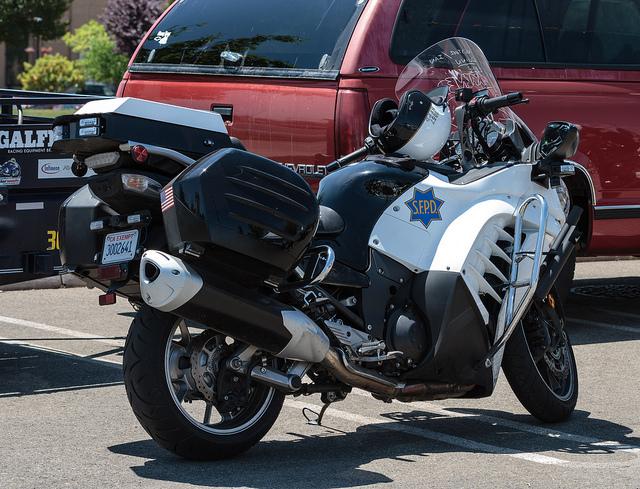Is the motorcycle parked?
Give a very brief answer. Yes. What is the plate number?
Quick response, please. 3002641. What is the state on the motorcycle's license plate?
Concise answer only. California. Is there a car in front of the bike?
Answer briefly. Yes. 